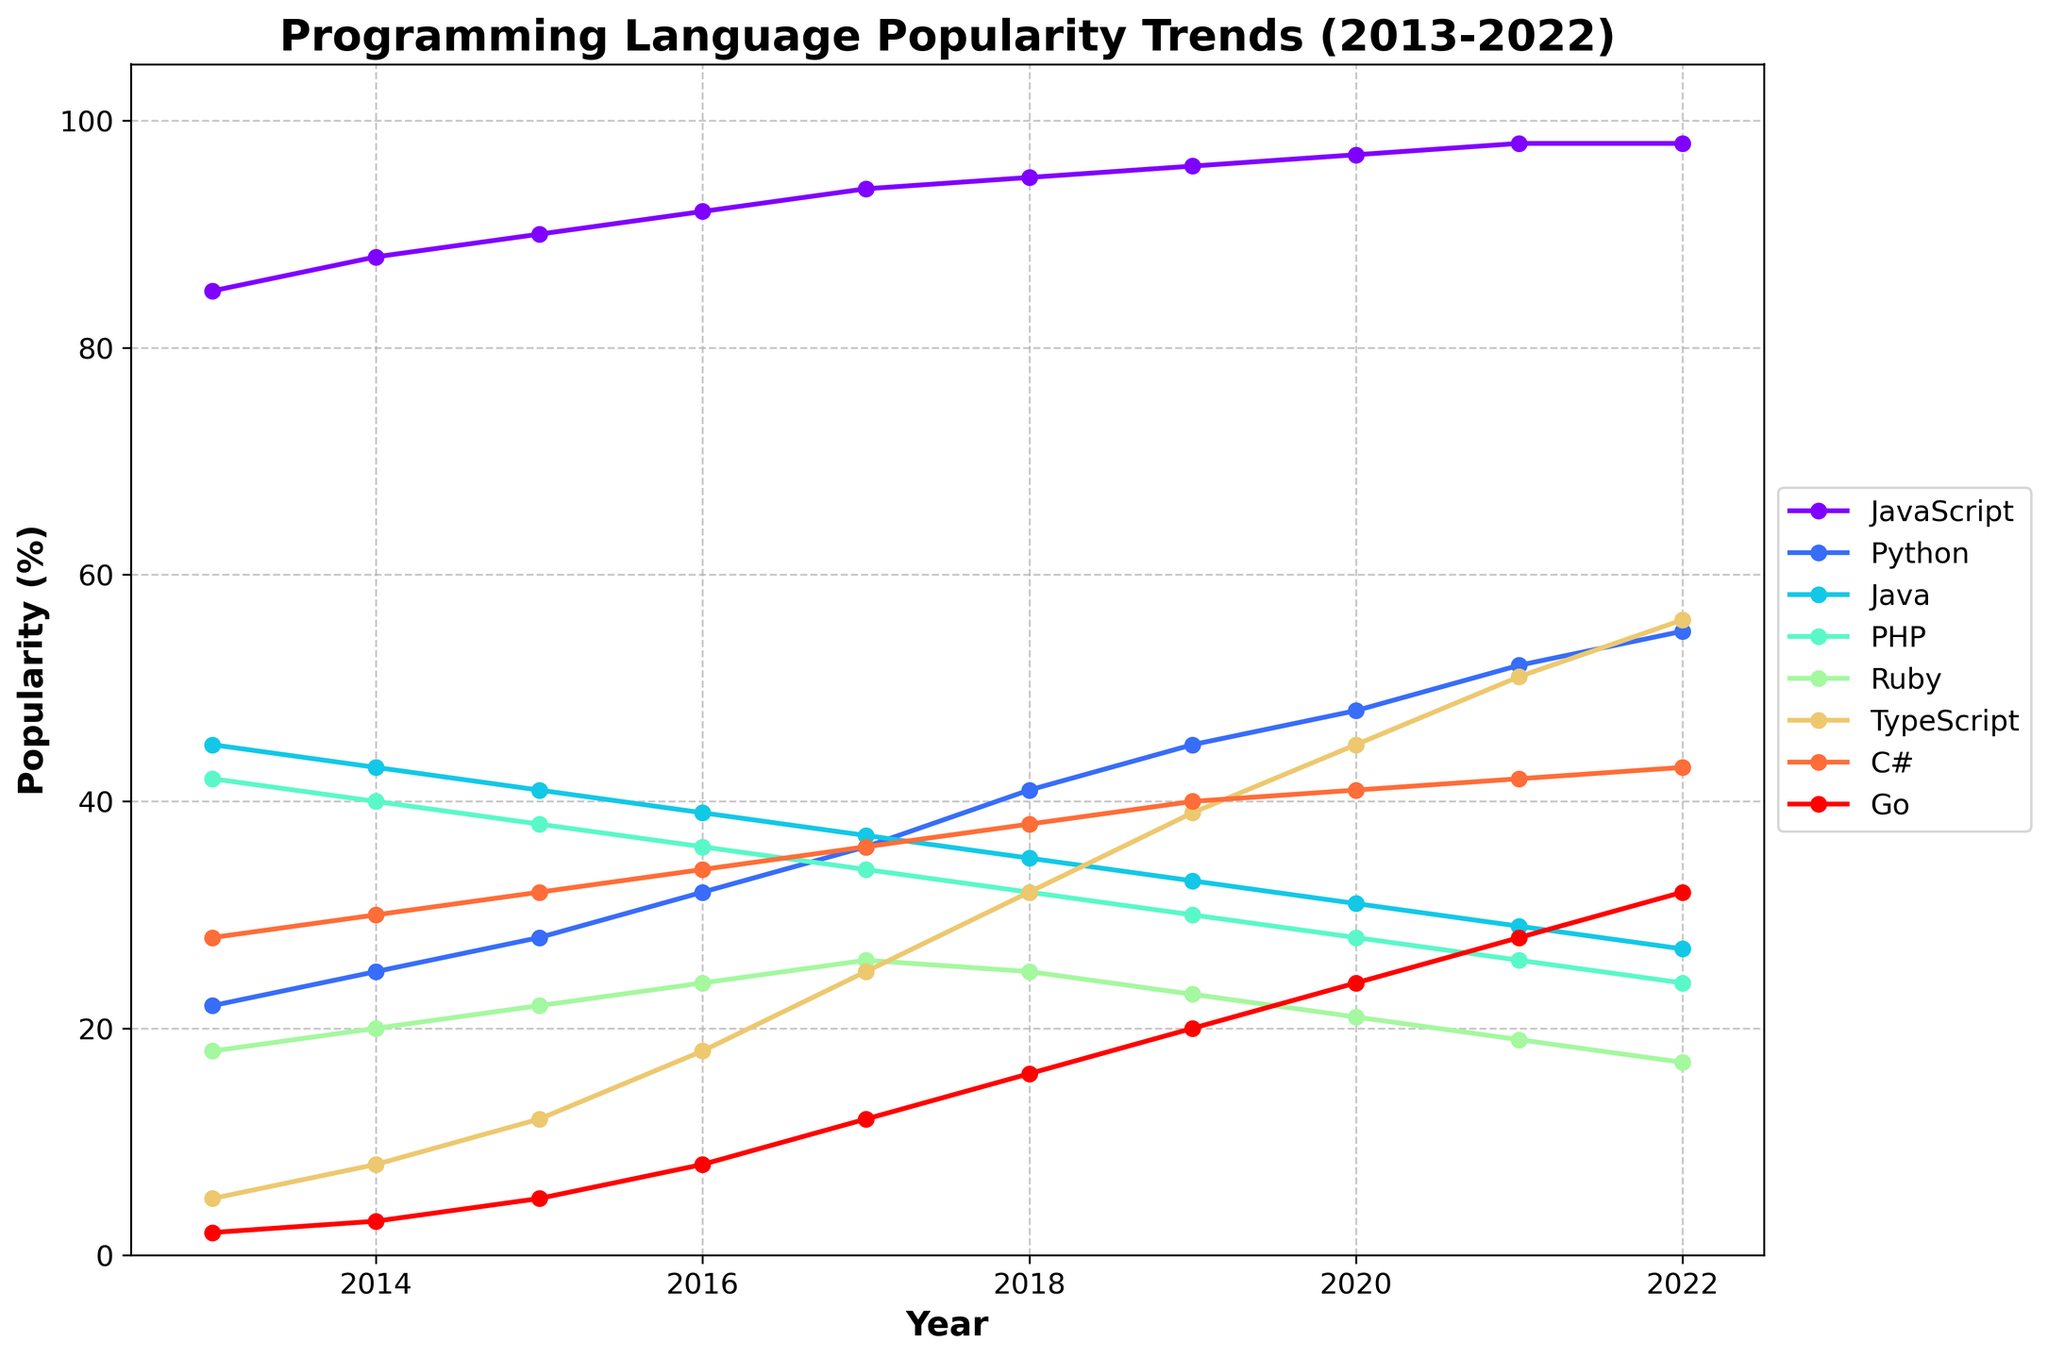What's the trend for JavaScript popularity from 2013 to 2022? JavaScript's popularity increases steadily from 85% in 2013 to 98% in 2022.
Answer: Steady increase Which programming language overtakes Ruby in popularity during the 2013-2022 period? TypeScript overtakes Ruby in 2018, continuing to increase its popularity while Ruby's popularity decreases.
Answer: TypeScript By how much did Python's popularity increase between 2013 and 2022? In 2013, Python's popularity was 22%, and by 2022, it had increased to 55%. So, the increase is 55% - 22%.
Answer: 33% Which year did PHP fall below 30% popularity? PHP fell below 30% in 2019, marked at 30% or lower from then on.
Answer: 2019 Compare the popularity trends of Java and C# from 2013 to 2022. Java's popularity decreases from 45% to 27%, while C# shows a slight increase from 28% to 43%.
Answer: Java decreases, C# increases What is the difference in popularity between TypeScript and Ruby in 2022? TypeScript's popularity in 2022 is 56%, and Ruby's is 17%. So, the difference is 56% - 17%.
Answer: 39% Find the year when Go's popularity first reached double digits. In 2017, Go's popularity reached 12%, marking the first time it hit double digits.
Answer: 2017 Which language had the most rapid increase in popularity over the period? TypeScript shows the most rapid increase, growing from 5% in 2013 to 56% in 2022.
Answer: TypeScript What was the average popularity of Java between 2013 and 2022? Java's popularity percentages from 2013 to 2022 are 45, 43, 41, 39, 37, 35, 33, 31, 29, and 27. The sum is 360, and the average is 360/10.
Answer: 36% Identify the language with the smallest change in popularity over the decade. JavaScript changes the least in popularity, starting at 85% in 2013 and ending at 98% in 2022.
Answer: JavaScript 